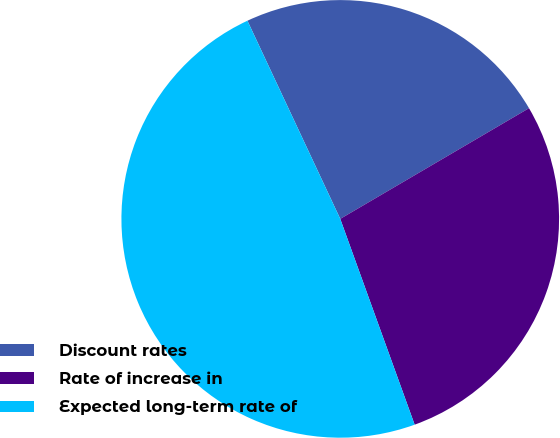Convert chart to OTSL. <chart><loc_0><loc_0><loc_500><loc_500><pie_chart><fcel>Discount rates<fcel>Rate of increase in<fcel>Expected long-term rate of<nl><fcel>23.53%<fcel>27.92%<fcel>48.55%<nl></chart> 